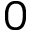<formula> <loc_0><loc_0><loc_500><loc_500>0</formula> 